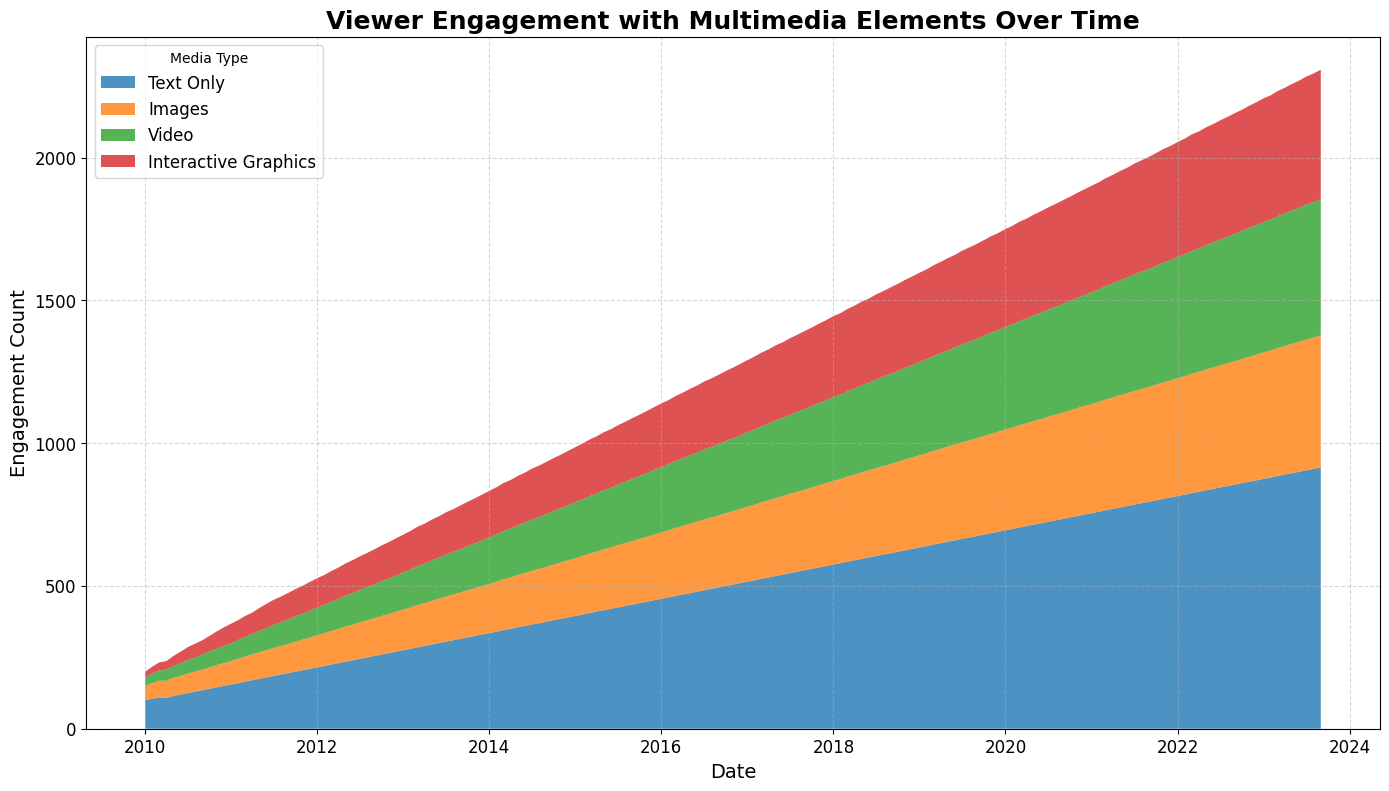What's the overall trend in viewer engagement over time? Viewer engagement for all media types shows an increasing trend over time, as seen by the upward slope of the areas in the chart. Starting from 2010, the engagement for all media types consistently increases until 2023.
Answer: Increasing trend Which media type had the highest viewer engagement in 2015? By looking at the figure, 'Text Only' had the highest viewer engagement in 2015. The 'Text Only' segment occupies the largest area at that period compared to other media types.
Answer: Text Only How does engagement with images compare to videos in December 2020? In December 2020, the engagement with Images is represented by the second layer from the bottom, and engagement with Video is the third layer. Visually, the area for Images is larger than the area for Video, indicating higher engagement with Images.
Answer: Images had higher engagement How did viewer engagement with Interactive Graphics change between 2010 and 2023? For Interactive Graphics, the bottom-most layer shows a gradual increase in its size from 2010 to 2023, indicating a steady rise in viewer engagement with this media type over the years.
Answer: Increased steadily By how much did engagement with Text Only content grow from January 2010 to September 2023? The engagement with Text Only content in January 2010 is 100, while in September 2023, it is 915. To find the growth, subtract the initial value from the final value: 915 - 100 = 815.
Answer: 815 Which media type had the least engagement consistently over the years? Referring to the smallest area color in the stacked area chart, Interactive Graphics consistently had the least engagement over the years from 2010 to 2023.
Answer: Interactive Graphics In which month did the viewer engagement for Videos surpass 150? By observing the Video area (green), it surpasses the 150 engagement mark around January 2013, as indicated by the increased area size beyond the 150 engagement line on the y-axis.
Answer: January 2013 What is the trend of viewer engagement for Interactive Graphics from 2018 to 2020? The area for Interactive Graphics shows a steady and consistent increase in size between 2018 and 2020, indicating a rising trend in viewer engagement for this media type during that period.
Answer: Increasing trend Which year saw the largest increase in engagement with Images? Observing the width of the area representing Images (orange), the largest jump is noticeable between 2010 and 2011, where the engagement increases from 50 to 82. No other year shows such a steep incline.
Answer: 2010-2011 What's the cumulative engagement for all media types in June 2015? To find the cumulative engagement, sum the engagement for all media types in June 2015: 420 (Text Only) + 215 (Images) + 209 (Video) + 205 (Interactive Graphics) = 1049.
Answer: 1049 